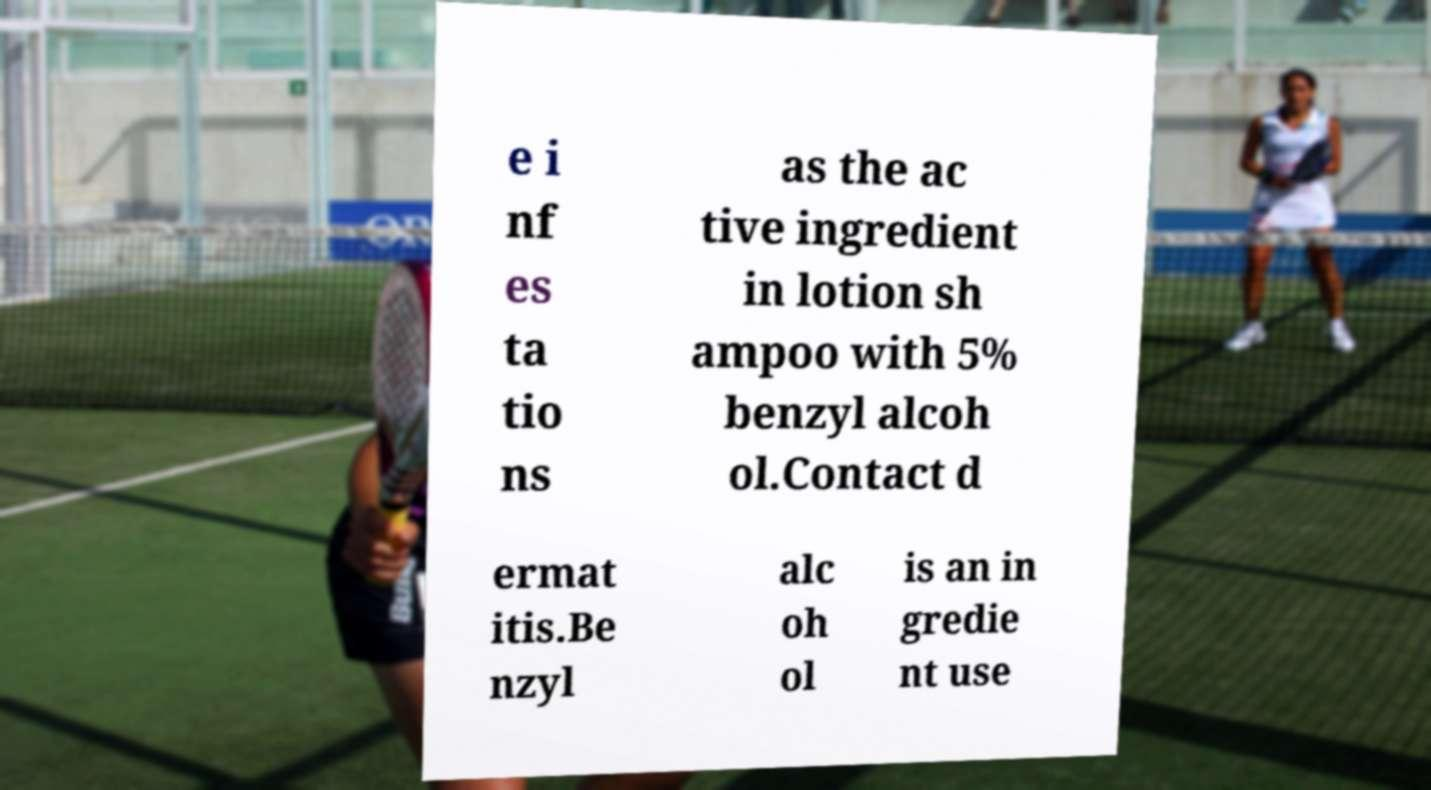Please read and relay the text visible in this image. What does it say? e i nf es ta tio ns as the ac tive ingredient in lotion sh ampoo with 5% benzyl alcoh ol.Contact d ermat itis.Be nzyl alc oh ol is an in gredie nt use 